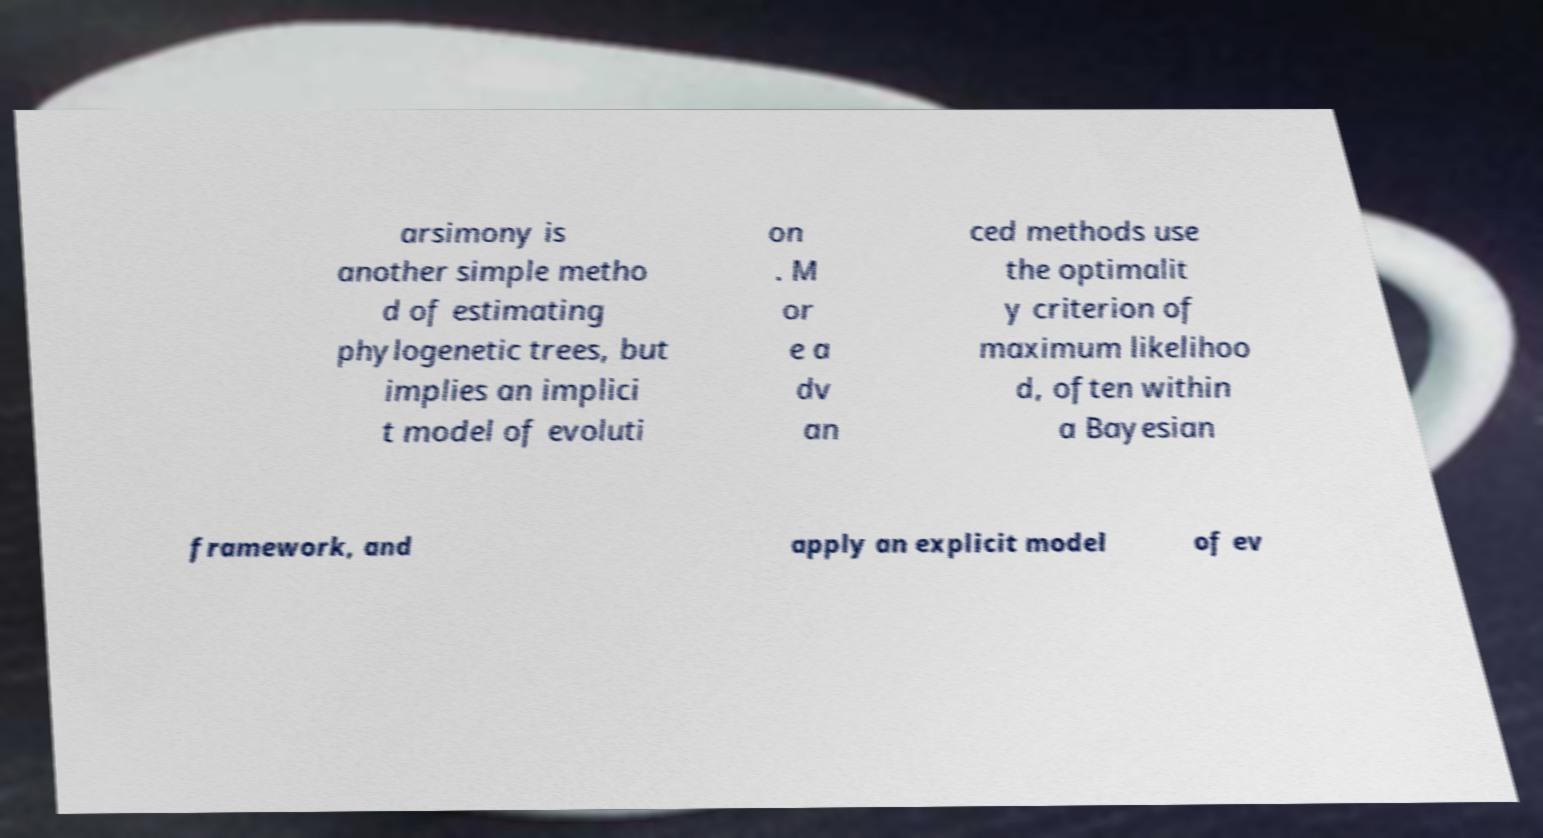What messages or text are displayed in this image? I need them in a readable, typed format. arsimony is another simple metho d of estimating phylogenetic trees, but implies an implici t model of evoluti on . M or e a dv an ced methods use the optimalit y criterion of maximum likelihoo d, often within a Bayesian framework, and apply an explicit model of ev 